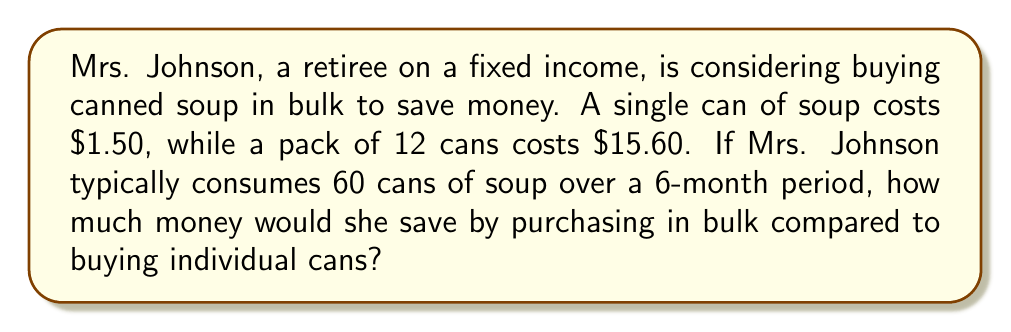Help me with this question. Let's approach this step-by-step:

1. Calculate the cost of buying individual cans:
   - Number of cans needed: 60
   - Cost per can: $1.50
   - Total cost: $60 \times $1.50 = $90

2. Calculate the cost of buying in bulk:
   - Number of cans needed: 60
   - Number of 12-can packs needed: $\frac{60}{12} = 5$ packs
   - Cost per pack: $15.60
   - Total cost: $5 \times $15.60 = $78

3. Calculate the savings:
   - Savings = Cost of individual cans - Cost of bulk purchase
   - Savings = $90 - $78 = $12

We can also express this as a percentage savings:
$$\text{Percentage savings} = \frac{\text{Savings}}{\text{Original cost}} \times 100\%$$
$$= \frac{$12}{$90} \times 100\% = 13.33\%$$

Therefore, Mrs. Johnson would save $12 over a 6-month period, which is equivalent to a 13.33% savings on her soup purchases.
Answer: Mrs. Johnson would save $12 by purchasing soup in bulk over a 6-month period. 